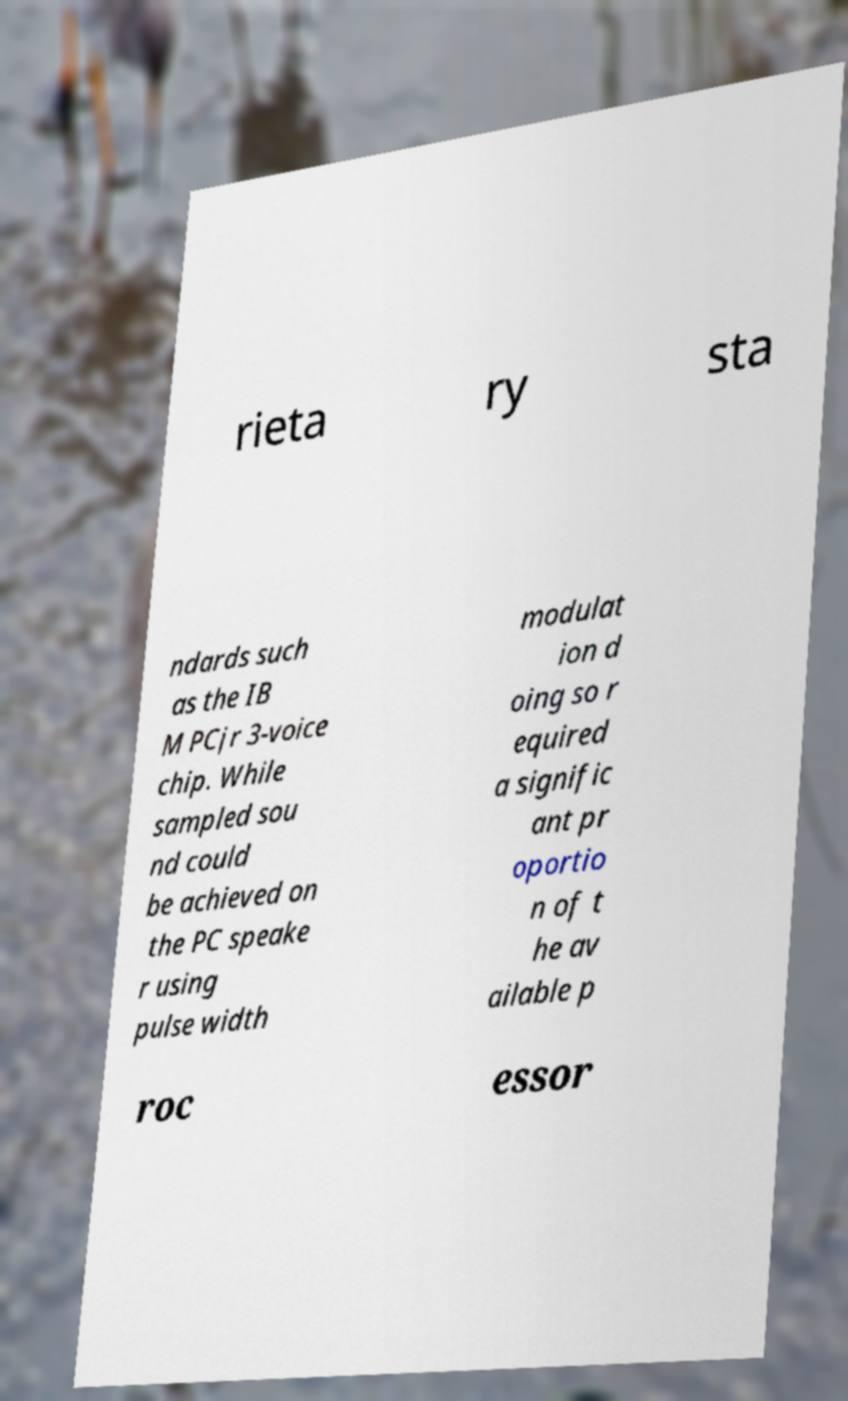Could you assist in decoding the text presented in this image and type it out clearly? rieta ry sta ndards such as the IB M PCjr 3-voice chip. While sampled sou nd could be achieved on the PC speake r using pulse width modulat ion d oing so r equired a signific ant pr oportio n of t he av ailable p roc essor 